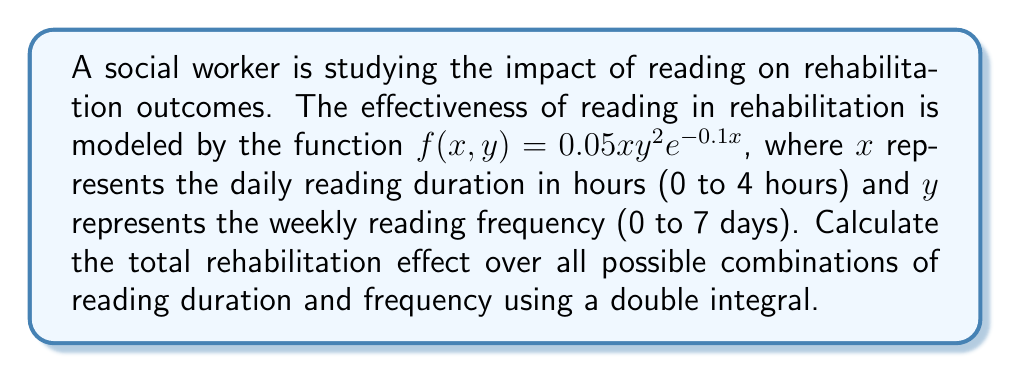Help me with this question. To solve this problem, we need to evaluate the double integral of the given function over the specified ranges for x and y.

1) Set up the double integral:
   $$\iint_R f(x,y) \, dy \, dx = \int_0^4 \int_0^7 0.05xy^2e^{-0.1x} \, dy \, dx$$

2) First, integrate with respect to y:
   $$\int_0^4 \left[\frac{0.05xy^3}{3}e^{-0.1x}\right]_0^7 \, dx$$
   $$= \int_0^4 \frac{0.05x(343)}{3}e^{-0.1x} \, dx$$
   $$= \frac{343}{60} \int_0^4 xe^{-0.1x} \, dx$$

3) To integrate $xe^{-0.1x}$, use integration by parts:
   Let $u = x$ and $dv = e^{-0.1x} \, dx$
   Then $du = dx$ and $v = -10e^{-0.1x}$

   $$\frac{343}{60} \left[-10xe^{-0.1x}\right]_0^4 - \frac{343}{60} \int_0^4 -10e^{-0.1x} \, dx$$

4) Evaluate the integral:
   $$\frac{343}{60} \left[-10xe^{-0.1x} + 100e^{-0.1x}\right]_0^4$$
   $$= \frac{343}{60} \left[(-40e^{-0.4} + 100e^{-0.4}) - (0 + 100)\right]$$
   $$= \frac{343}{60} \left[60e^{-0.4} - 100\right]$$

5) Simplify:
   $$= 343 \left[e^{-0.4} - \frac{5}{3}\right]$$
   $$\approx 343 \cdot 0.0179 \approx 6.14$$
Answer: The total rehabilitation effect is approximately 6.14 units. 